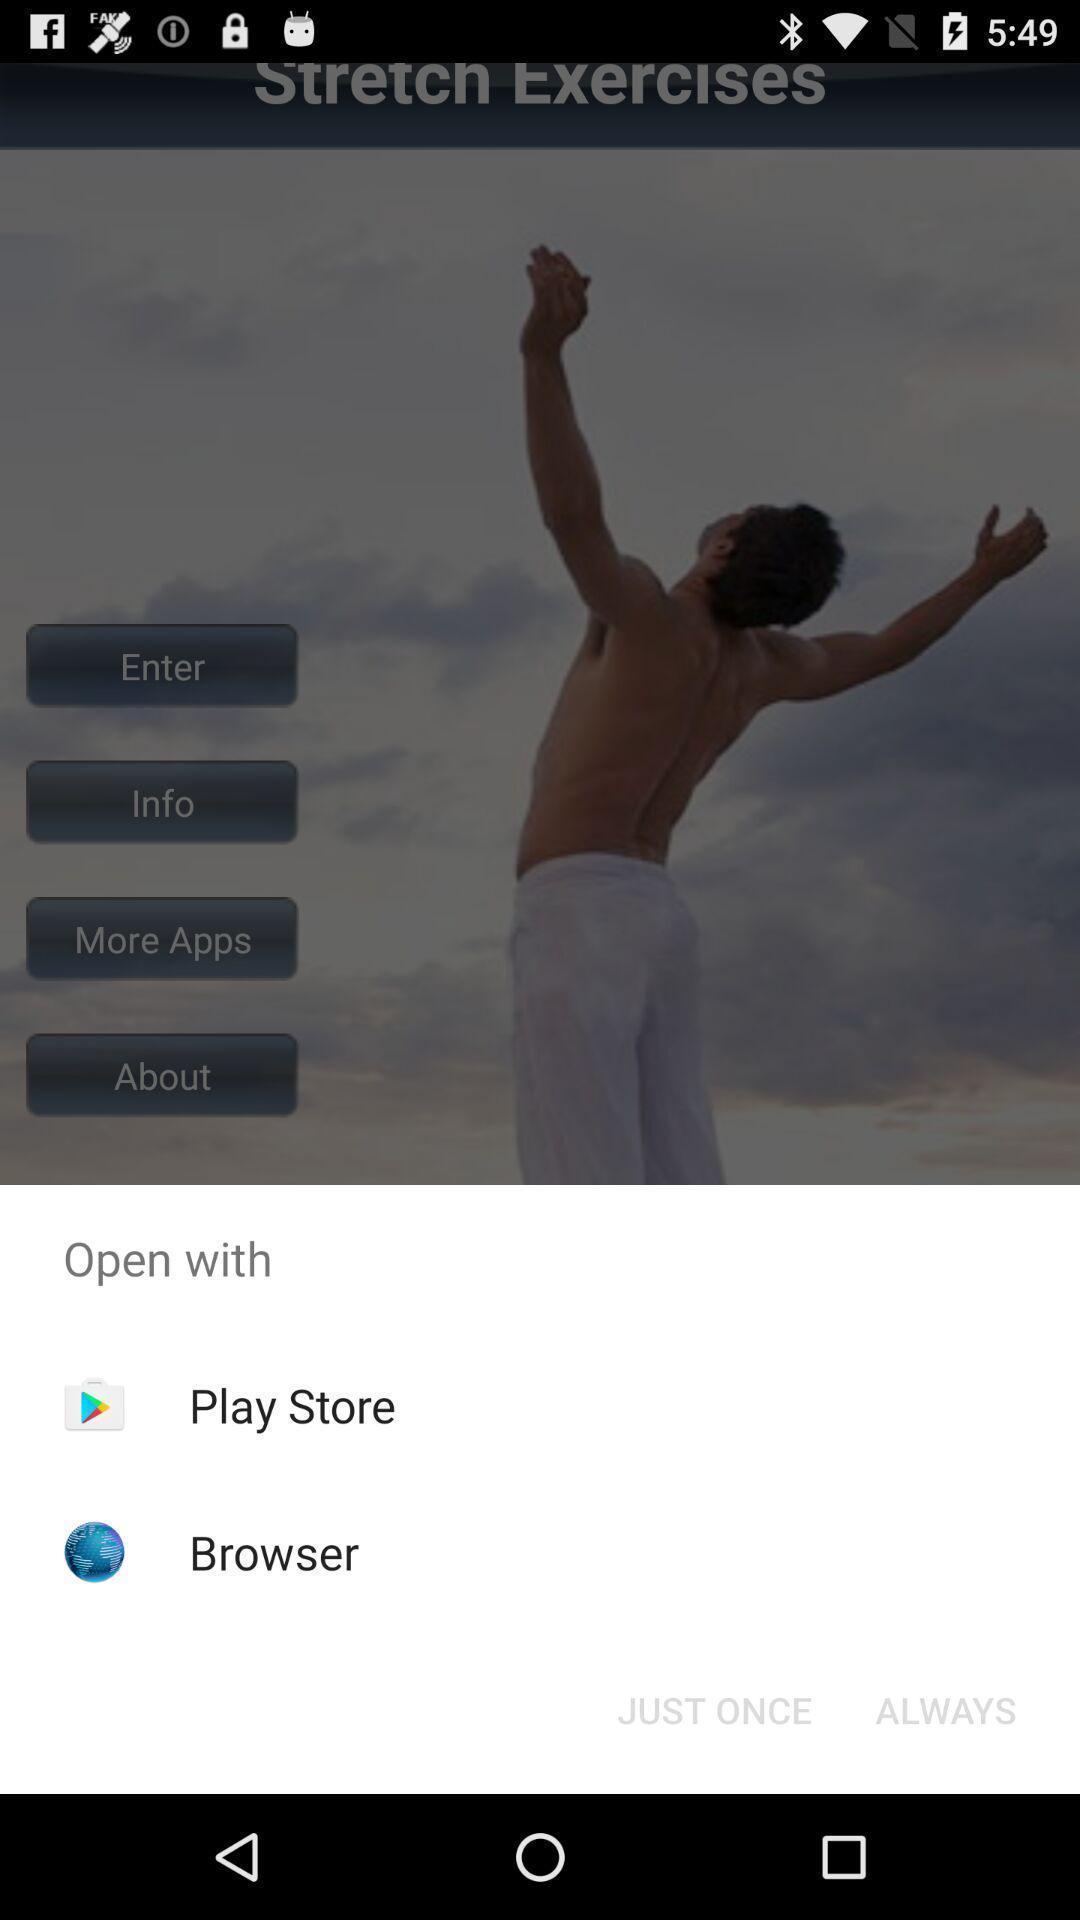Summarize the main components in this picture. Pop-up shows open with multiple applications. 